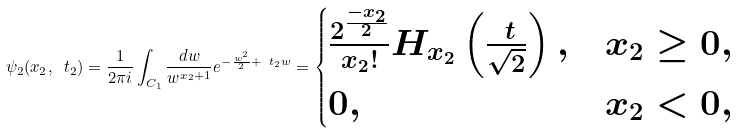<formula> <loc_0><loc_0><loc_500><loc_500>\psi _ { 2 } ( x _ { 2 } , \ t _ { 2 } ) = \frac { 1 } { 2 \pi i } \int _ { C _ { 1 } } \frac { d w } { w ^ { x _ { 2 } + 1 } } e ^ { - \frac { w ^ { 2 } } { 2 } + \ t _ { 2 } w } = \begin{cases} \frac { 2 ^ { \frac { - x _ { 2 } } { 2 } } } { x _ { 2 } ! } H _ { x _ { 2 } } \left ( \frac { \ t } { \sqrt { 2 } } \right ) , & x _ { 2 } \geq 0 , \\ 0 , & x _ { 2 } < 0 , \end{cases}</formula> 